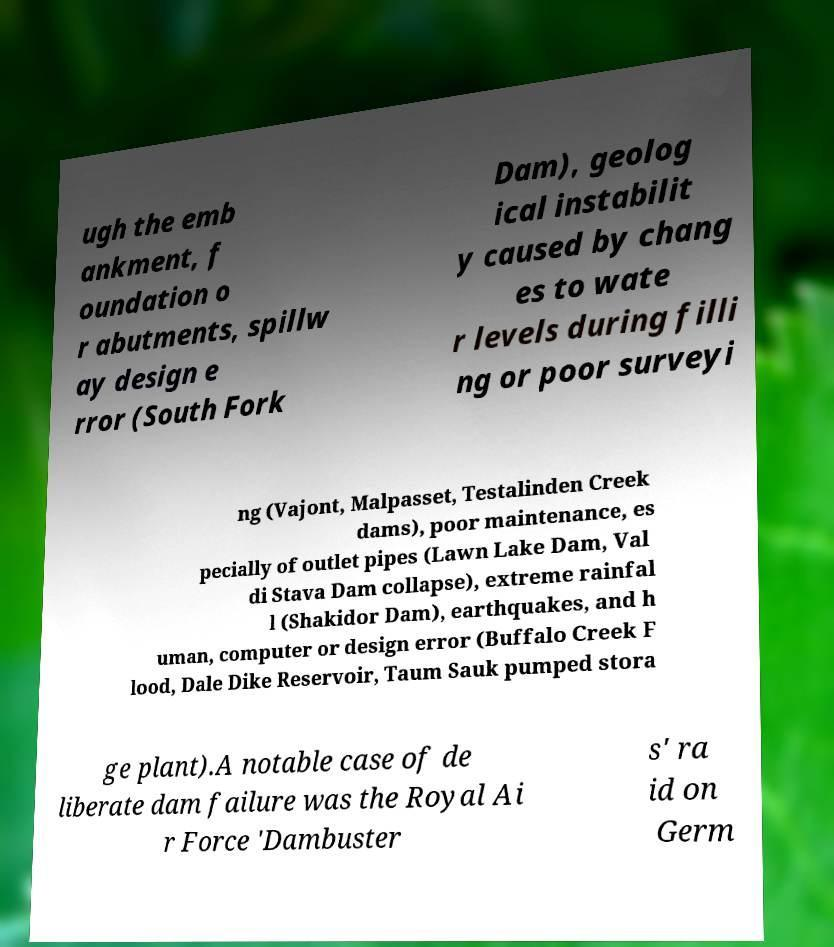For documentation purposes, I need the text within this image transcribed. Could you provide that? ugh the emb ankment, f oundation o r abutments, spillw ay design e rror (South Fork Dam), geolog ical instabilit y caused by chang es to wate r levels during filli ng or poor surveyi ng (Vajont, Malpasset, Testalinden Creek dams), poor maintenance, es pecially of outlet pipes (Lawn Lake Dam, Val di Stava Dam collapse), extreme rainfal l (Shakidor Dam), earthquakes, and h uman, computer or design error (Buffalo Creek F lood, Dale Dike Reservoir, Taum Sauk pumped stora ge plant).A notable case of de liberate dam failure was the Royal Ai r Force 'Dambuster s' ra id on Germ 